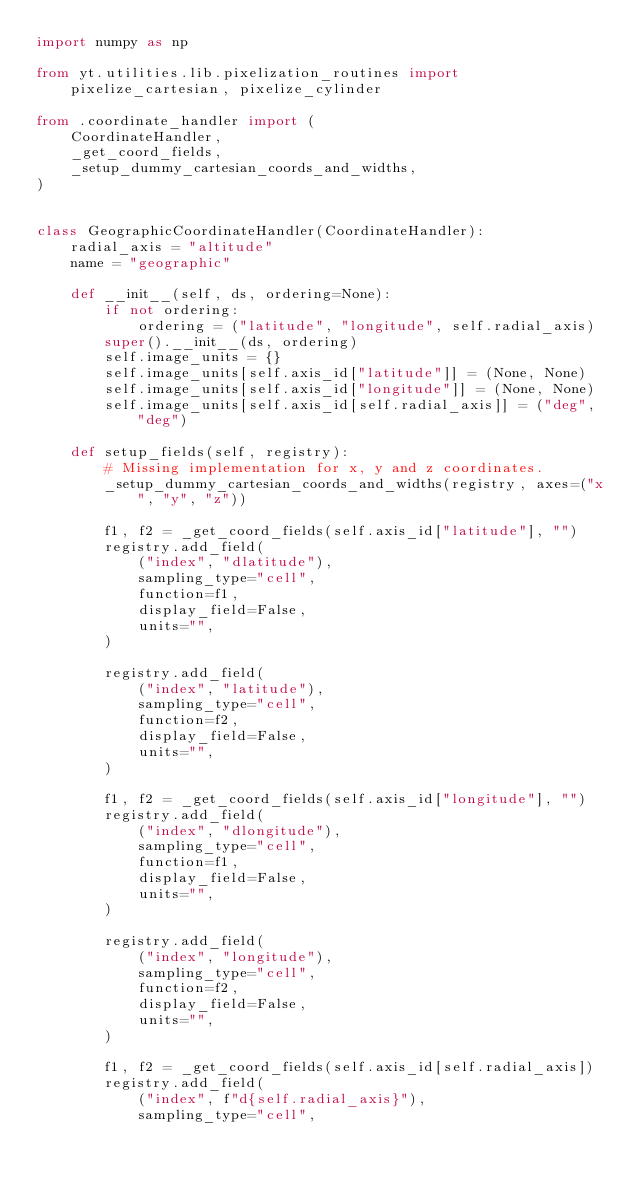Convert code to text. <code><loc_0><loc_0><loc_500><loc_500><_Python_>import numpy as np

from yt.utilities.lib.pixelization_routines import pixelize_cartesian, pixelize_cylinder

from .coordinate_handler import (
    CoordinateHandler,
    _get_coord_fields,
    _setup_dummy_cartesian_coords_and_widths,
)


class GeographicCoordinateHandler(CoordinateHandler):
    radial_axis = "altitude"
    name = "geographic"

    def __init__(self, ds, ordering=None):
        if not ordering:
            ordering = ("latitude", "longitude", self.radial_axis)
        super().__init__(ds, ordering)
        self.image_units = {}
        self.image_units[self.axis_id["latitude"]] = (None, None)
        self.image_units[self.axis_id["longitude"]] = (None, None)
        self.image_units[self.axis_id[self.radial_axis]] = ("deg", "deg")

    def setup_fields(self, registry):
        # Missing implementation for x, y and z coordinates.
        _setup_dummy_cartesian_coords_and_widths(registry, axes=("x", "y", "z"))

        f1, f2 = _get_coord_fields(self.axis_id["latitude"], "")
        registry.add_field(
            ("index", "dlatitude"),
            sampling_type="cell",
            function=f1,
            display_field=False,
            units="",
        )

        registry.add_field(
            ("index", "latitude"),
            sampling_type="cell",
            function=f2,
            display_field=False,
            units="",
        )

        f1, f2 = _get_coord_fields(self.axis_id["longitude"], "")
        registry.add_field(
            ("index", "dlongitude"),
            sampling_type="cell",
            function=f1,
            display_field=False,
            units="",
        )

        registry.add_field(
            ("index", "longitude"),
            sampling_type="cell",
            function=f2,
            display_field=False,
            units="",
        )

        f1, f2 = _get_coord_fields(self.axis_id[self.radial_axis])
        registry.add_field(
            ("index", f"d{self.radial_axis}"),
            sampling_type="cell",</code> 